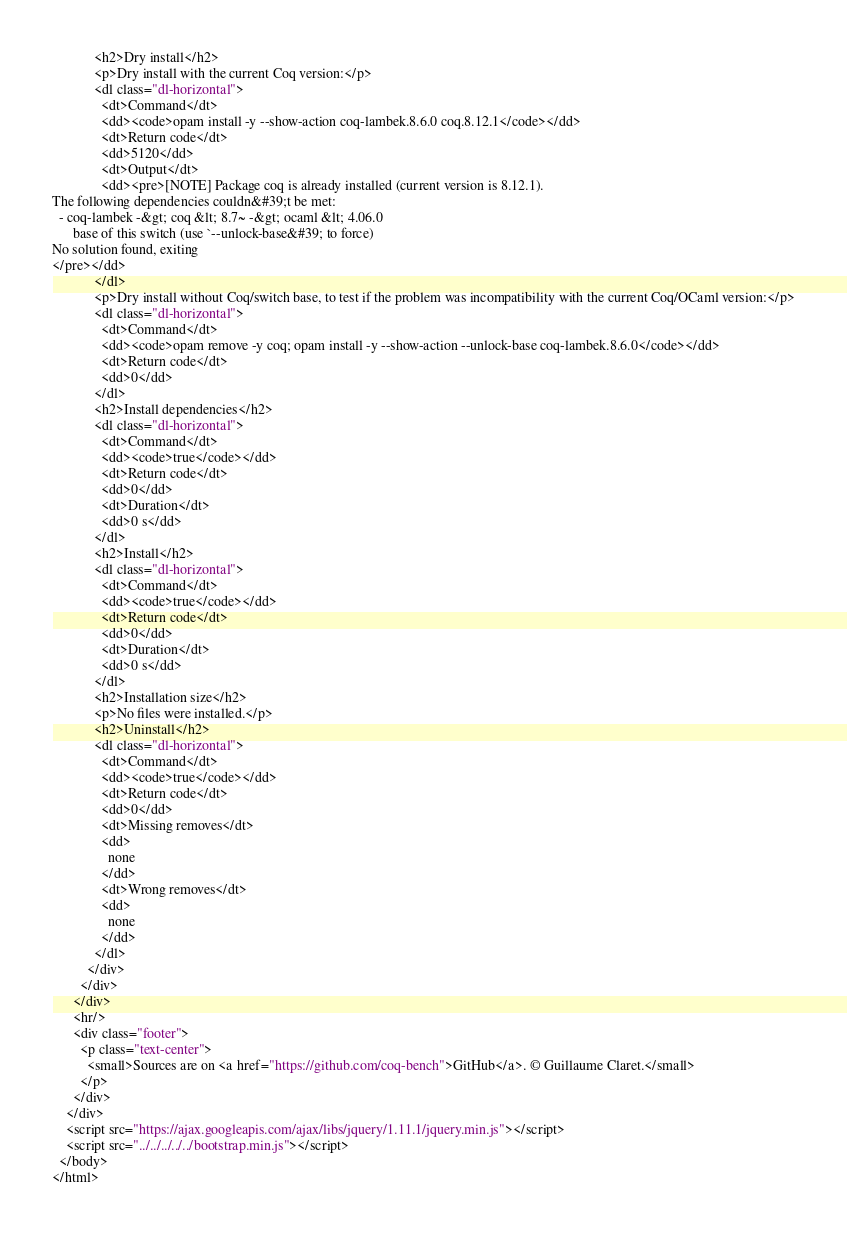Convert code to text. <code><loc_0><loc_0><loc_500><loc_500><_HTML_>            <h2>Dry install</h2>
            <p>Dry install with the current Coq version:</p>
            <dl class="dl-horizontal">
              <dt>Command</dt>
              <dd><code>opam install -y --show-action coq-lambek.8.6.0 coq.8.12.1</code></dd>
              <dt>Return code</dt>
              <dd>5120</dd>
              <dt>Output</dt>
              <dd><pre>[NOTE] Package coq is already installed (current version is 8.12.1).
The following dependencies couldn&#39;t be met:
  - coq-lambek -&gt; coq &lt; 8.7~ -&gt; ocaml &lt; 4.06.0
      base of this switch (use `--unlock-base&#39; to force)
No solution found, exiting
</pre></dd>
            </dl>
            <p>Dry install without Coq/switch base, to test if the problem was incompatibility with the current Coq/OCaml version:</p>
            <dl class="dl-horizontal">
              <dt>Command</dt>
              <dd><code>opam remove -y coq; opam install -y --show-action --unlock-base coq-lambek.8.6.0</code></dd>
              <dt>Return code</dt>
              <dd>0</dd>
            </dl>
            <h2>Install dependencies</h2>
            <dl class="dl-horizontal">
              <dt>Command</dt>
              <dd><code>true</code></dd>
              <dt>Return code</dt>
              <dd>0</dd>
              <dt>Duration</dt>
              <dd>0 s</dd>
            </dl>
            <h2>Install</h2>
            <dl class="dl-horizontal">
              <dt>Command</dt>
              <dd><code>true</code></dd>
              <dt>Return code</dt>
              <dd>0</dd>
              <dt>Duration</dt>
              <dd>0 s</dd>
            </dl>
            <h2>Installation size</h2>
            <p>No files were installed.</p>
            <h2>Uninstall</h2>
            <dl class="dl-horizontal">
              <dt>Command</dt>
              <dd><code>true</code></dd>
              <dt>Return code</dt>
              <dd>0</dd>
              <dt>Missing removes</dt>
              <dd>
                none
              </dd>
              <dt>Wrong removes</dt>
              <dd>
                none
              </dd>
            </dl>
          </div>
        </div>
      </div>
      <hr/>
      <div class="footer">
        <p class="text-center">
          <small>Sources are on <a href="https://github.com/coq-bench">GitHub</a>. © Guillaume Claret.</small>
        </p>
      </div>
    </div>
    <script src="https://ajax.googleapis.com/ajax/libs/jquery/1.11.1/jquery.min.js"></script>
    <script src="../../../../../bootstrap.min.js"></script>
  </body>
</html>
</code> 